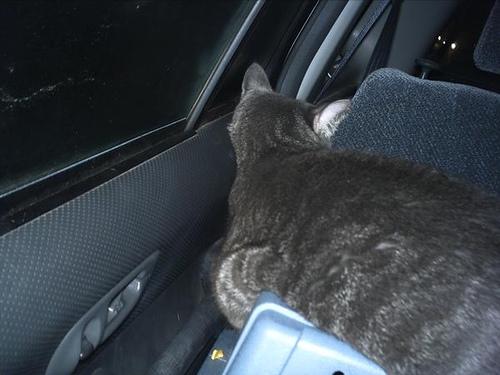Is the cat looking out the window?
Be succinct. No. Is the cat in a carrier?
Answer briefly. No. What two car parts are below the cat?
Concise answer only. Seat. How many cats are there?
Give a very brief answer. 1. 